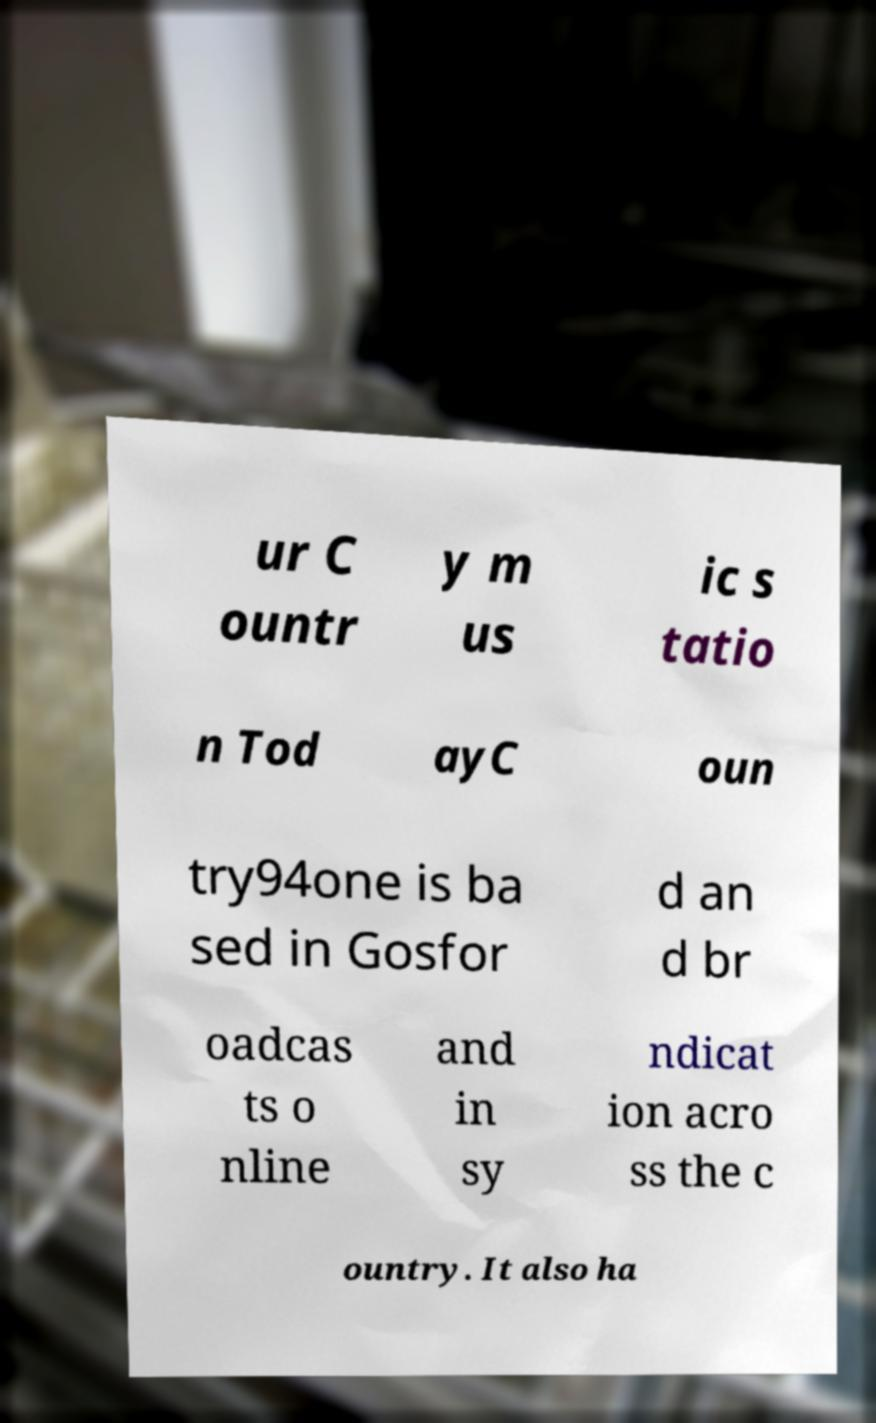Could you extract and type out the text from this image? ur C ountr y m us ic s tatio n Tod ayC oun try94one is ba sed in Gosfor d an d br oadcas ts o nline and in sy ndicat ion acro ss the c ountry. It also ha 